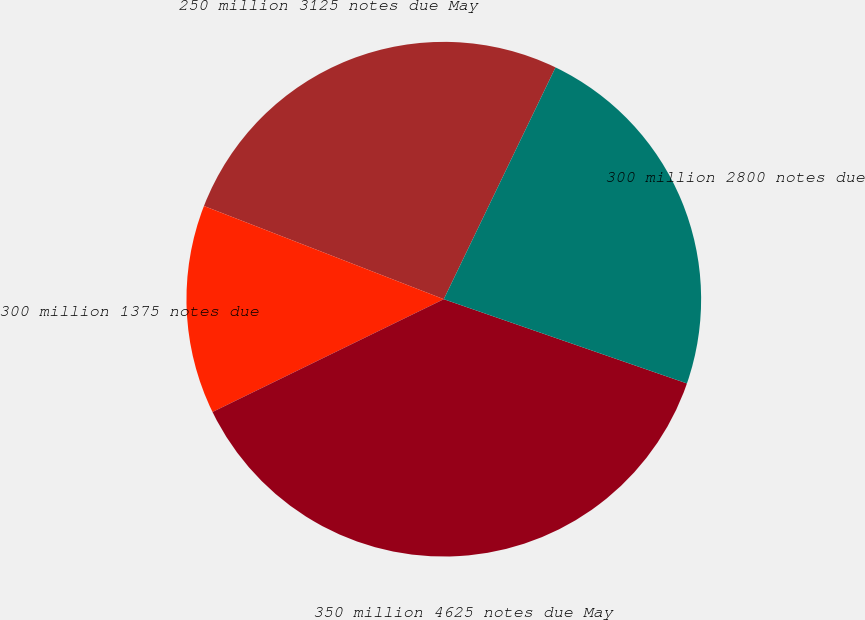<chart> <loc_0><loc_0><loc_500><loc_500><pie_chart><fcel>250 million 3125 notes due May<fcel>300 million 1375 notes due<fcel>350 million 4625 notes due May<fcel>300 million 2800 notes due<nl><fcel>26.25%<fcel>13.12%<fcel>37.47%<fcel>23.16%<nl></chart> 